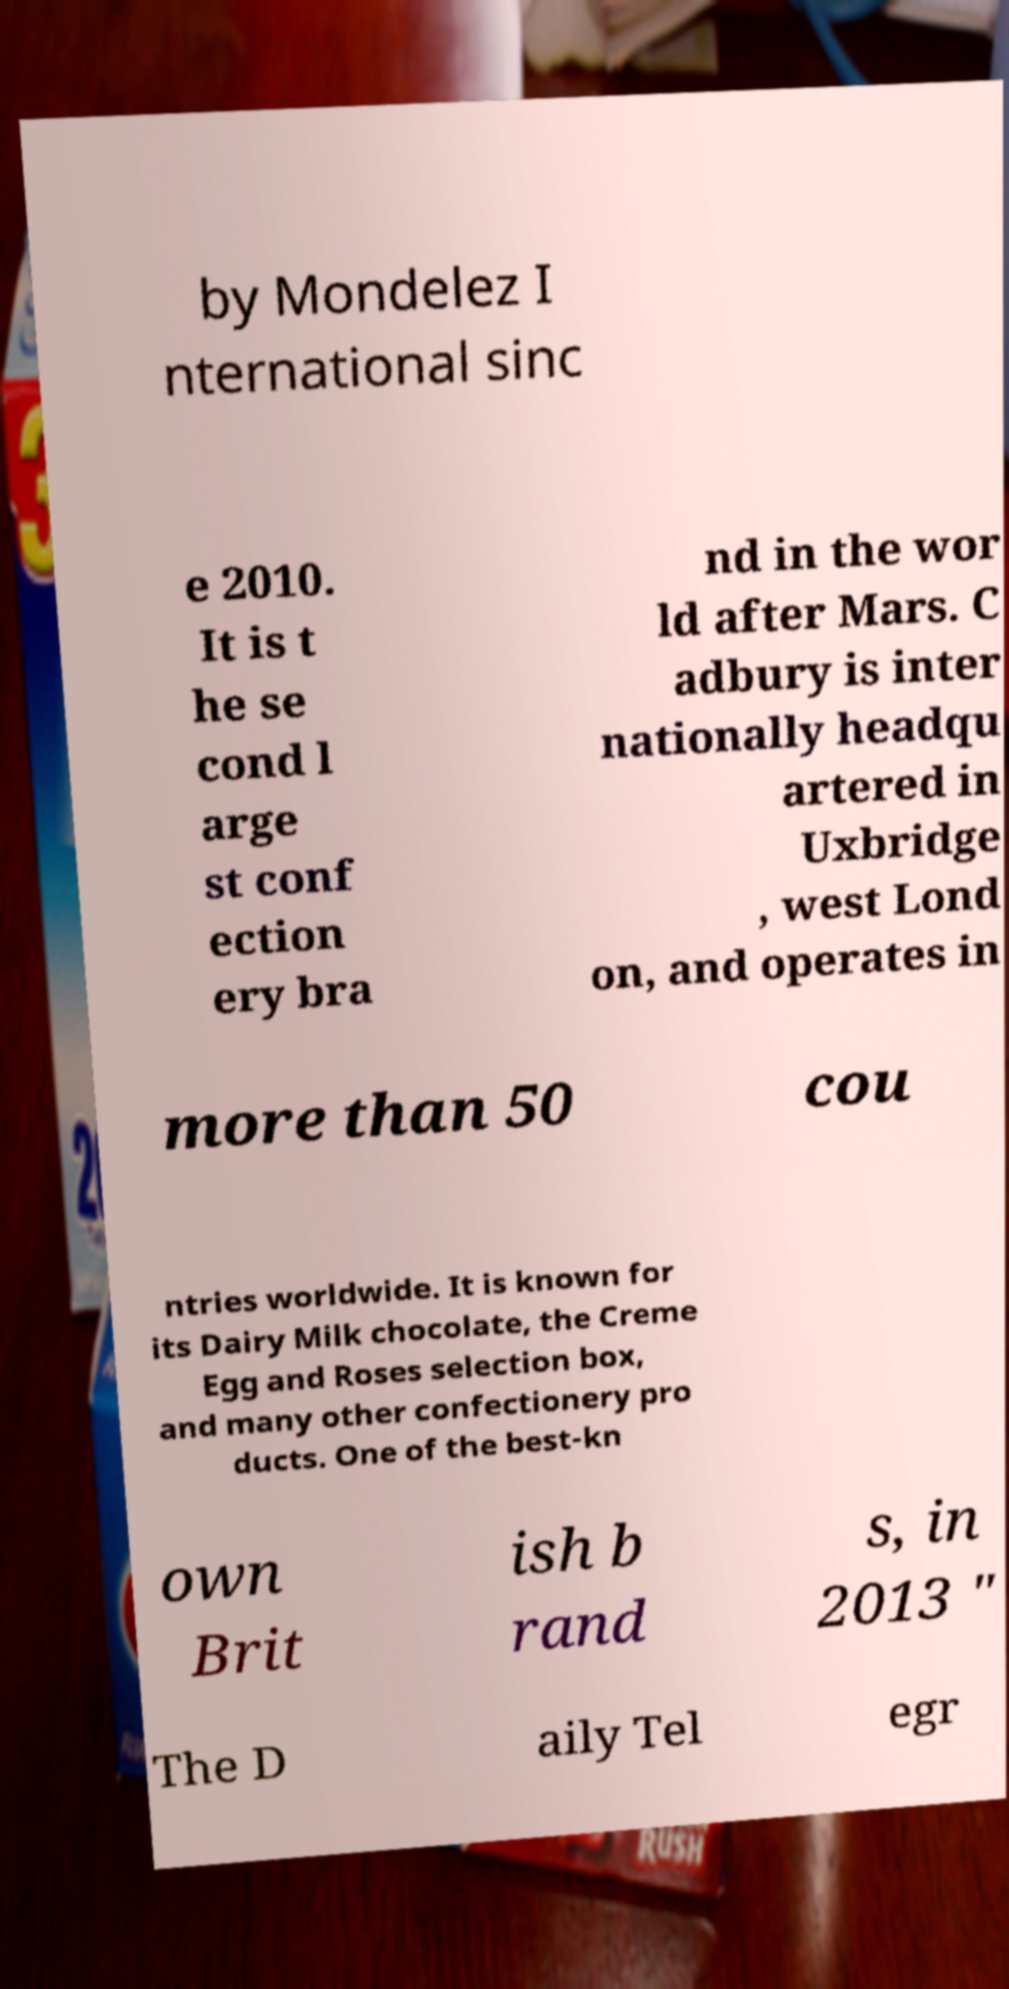Please read and relay the text visible in this image. What does it say? by Mondelez I nternational sinc e 2010. It is t he se cond l arge st conf ection ery bra nd in the wor ld after Mars. C adbury is inter nationally headqu artered in Uxbridge , west Lond on, and operates in more than 50 cou ntries worldwide. It is known for its Dairy Milk chocolate, the Creme Egg and Roses selection box, and many other confectionery pro ducts. One of the best-kn own Brit ish b rand s, in 2013 " The D aily Tel egr 